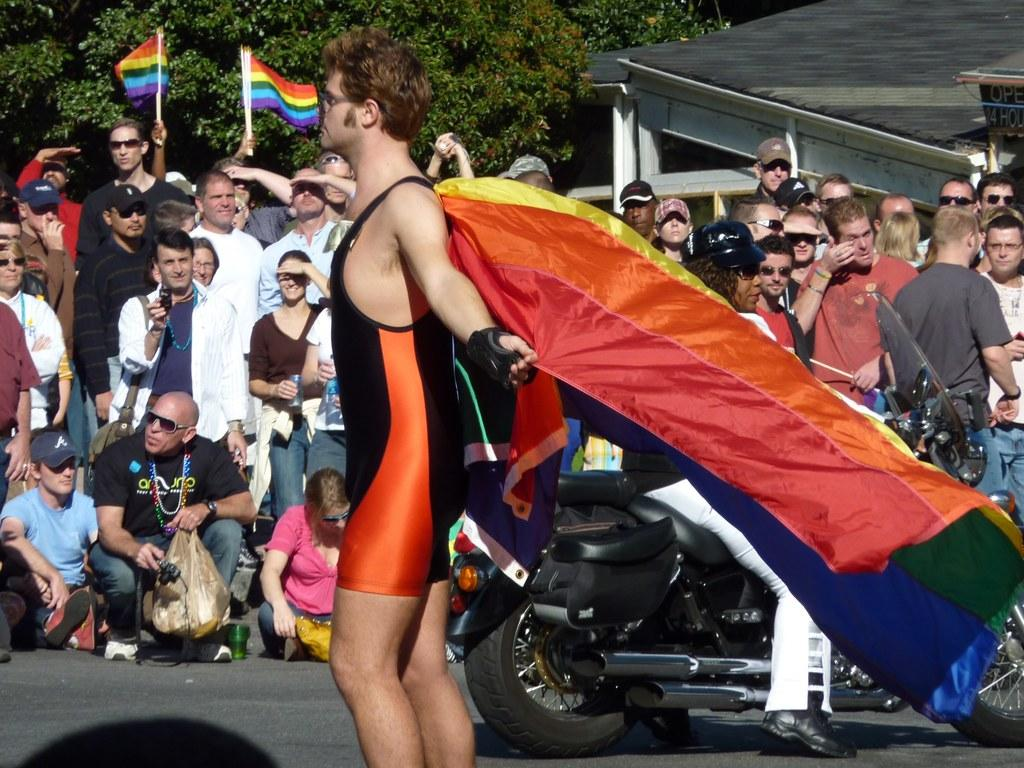What is the man in the image holding? The man is holding a flag. What can be seen in the background of the image? There is a person on a bike and other people in the background of the image. What are the people in the background doing? The people in the background are looking somewhere. What type of vegetation is visible in the background of the image? Trees are visible in the background of the image. What type of flower is being used to paste the selection on the wall in the image? There is no flower or paste present in the image. 